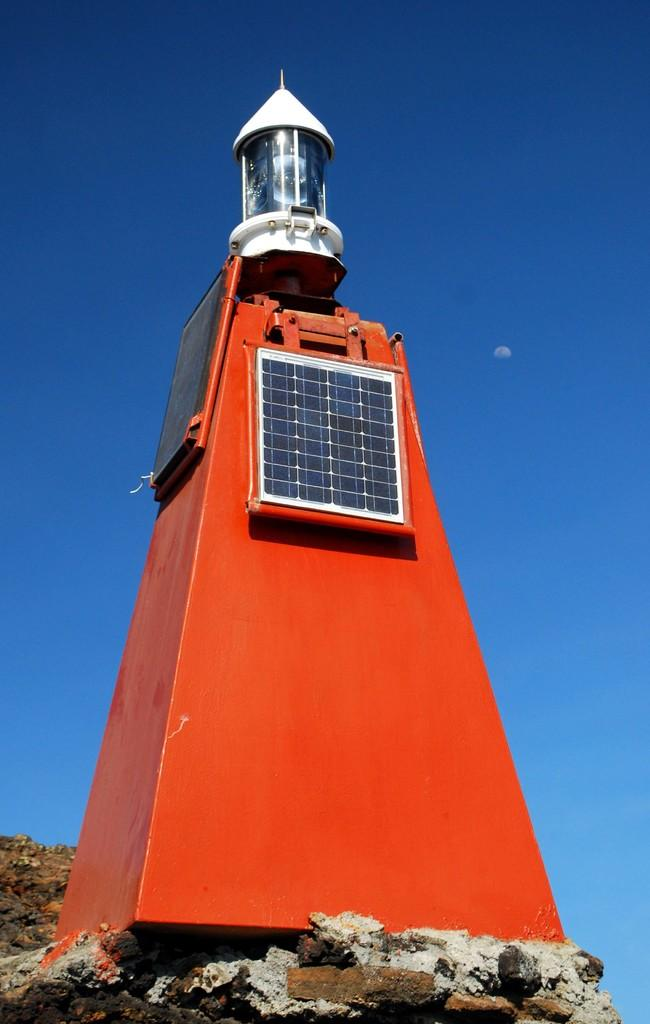What is the main subject of the image? There is a tower in the image. What colors are used to paint the tower? The tower is red and white. What can be seen in the background of the image? The sky is visible in the background of the image. Can you tell me how many stomachs the tower has in the image? There are no stomachs present in the image, as the main subject is a tower. 